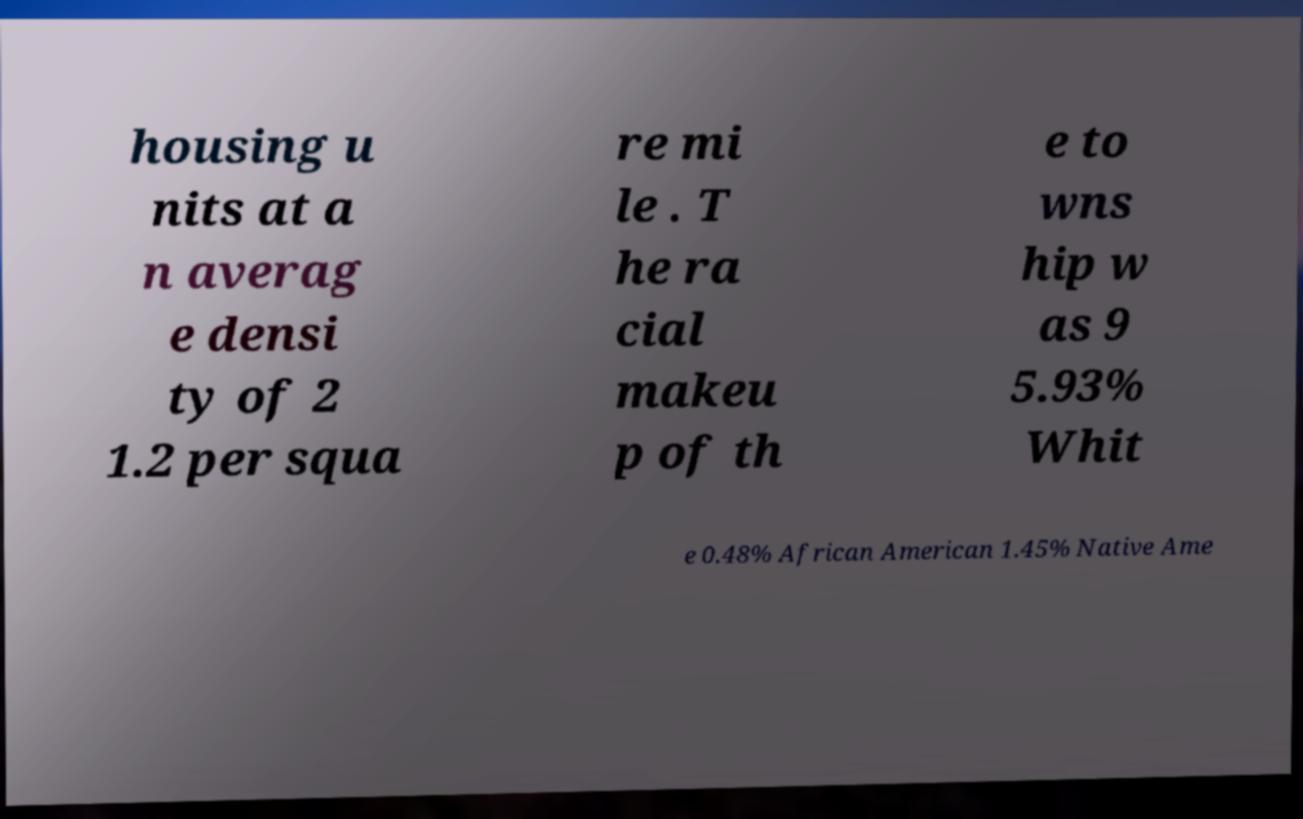There's text embedded in this image that I need extracted. Can you transcribe it verbatim? housing u nits at a n averag e densi ty of 2 1.2 per squa re mi le . T he ra cial makeu p of th e to wns hip w as 9 5.93% Whit e 0.48% African American 1.45% Native Ame 